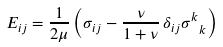Convert formula to latex. <formula><loc_0><loc_0><loc_500><loc_500>E _ { i j } = \frac { 1 } { 2 \mu } \left ( \sigma _ { i j } - \frac { \nu } { 1 + \nu } \, \delta _ { i j } \sigma ^ { k } _ { \ k } \right )</formula> 